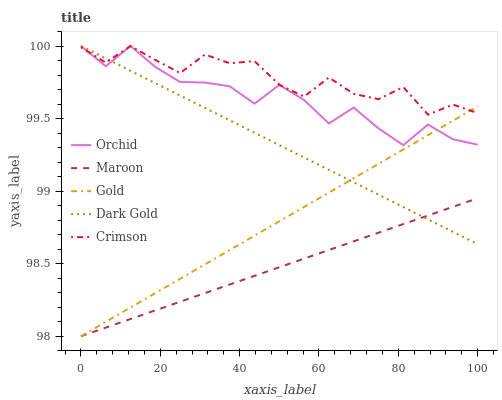Does Maroon have the minimum area under the curve?
Answer yes or no. Yes. Does Crimson have the maximum area under the curve?
Answer yes or no. Yes. Does Dark Gold have the minimum area under the curve?
Answer yes or no. No. Does Dark Gold have the maximum area under the curve?
Answer yes or no. No. Is Gold the smoothest?
Answer yes or no. Yes. Is Crimson the roughest?
Answer yes or no. Yes. Is Dark Gold the smoothest?
Answer yes or no. No. Is Dark Gold the roughest?
Answer yes or no. No. Does Gold have the lowest value?
Answer yes or no. Yes. Does Dark Gold have the lowest value?
Answer yes or no. No. Does Orchid have the highest value?
Answer yes or no. Yes. Does Gold have the highest value?
Answer yes or no. No. Is Maroon less than Orchid?
Answer yes or no. Yes. Is Orchid greater than Maroon?
Answer yes or no. Yes. Does Dark Gold intersect Crimson?
Answer yes or no. Yes. Is Dark Gold less than Crimson?
Answer yes or no. No. Is Dark Gold greater than Crimson?
Answer yes or no. No. Does Maroon intersect Orchid?
Answer yes or no. No. 